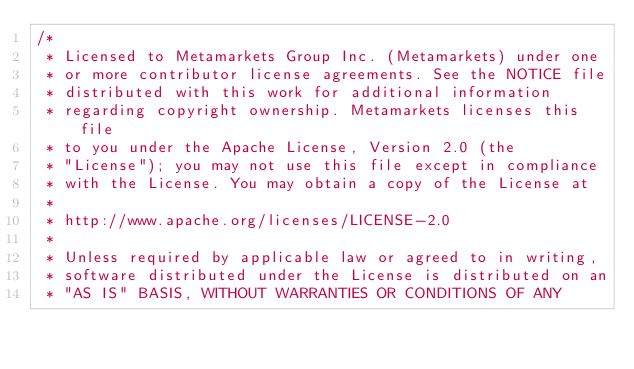Convert code to text. <code><loc_0><loc_0><loc_500><loc_500><_Java_>/*
 * Licensed to Metamarkets Group Inc. (Metamarkets) under one
 * or more contributor license agreements. See the NOTICE file
 * distributed with this work for additional information
 * regarding copyright ownership. Metamarkets licenses this file
 * to you under the Apache License, Version 2.0 (the
 * "License"); you may not use this file except in compliance
 * with the License. You may obtain a copy of the License at
 *
 * http://www.apache.org/licenses/LICENSE-2.0
 *
 * Unless required by applicable law or agreed to in writing,
 * software distributed under the License is distributed on an
 * "AS IS" BASIS, WITHOUT WARRANTIES OR CONDITIONS OF ANY</code> 